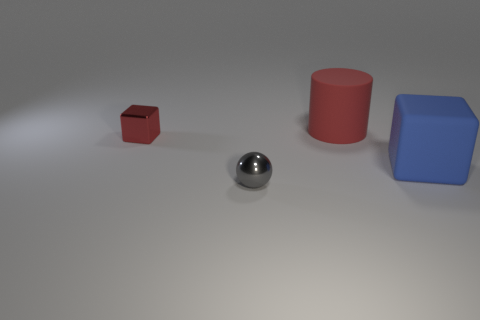What number of other things are there of the same color as the large rubber cylinder?
Make the answer very short. 1. There is a matte thing behind the big matte object that is in front of the red matte cylinder; what color is it?
Ensure brevity in your answer.  Red. Are there any other large rubber cubes of the same color as the rubber cube?
Ensure brevity in your answer.  No. How many shiny things are either big gray cylinders or balls?
Make the answer very short. 1. Is there a small yellow block that has the same material as the cylinder?
Your answer should be compact. No. How many objects are both left of the large cylinder and in front of the tiny cube?
Offer a terse response. 1. Is the number of big objects that are behind the large blue matte thing less than the number of rubber blocks behind the red cube?
Keep it short and to the point. No. Do the red shiny thing and the blue thing have the same shape?
Make the answer very short. Yes. How many objects are tiny things to the left of the gray sphere or things that are in front of the large rubber cylinder?
Provide a succinct answer. 3. What number of other metallic objects have the same shape as the small gray shiny object?
Provide a succinct answer. 0. 